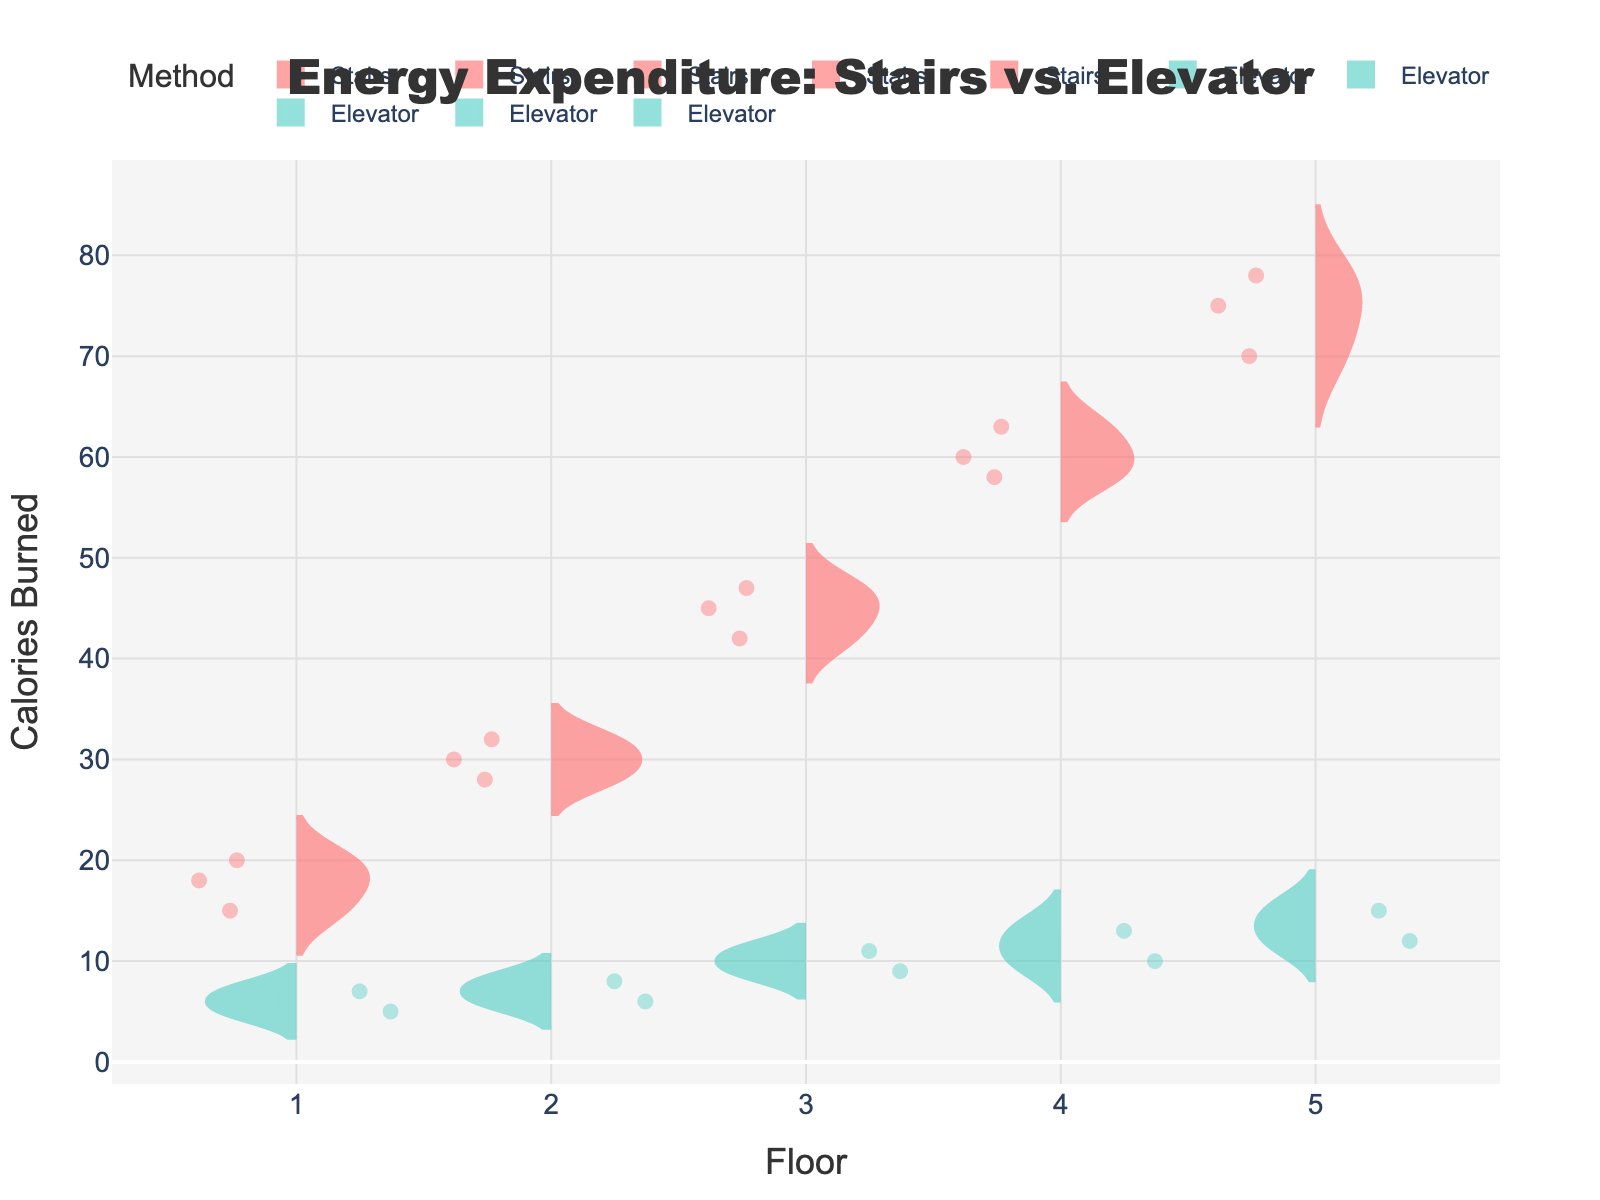How many colors are used in the violin plot? The figure uses two distinct colors to represent different methods (Stairs and Elevator). These colors help in distinguishing between the two methods visually.
Answer: Two What is the title of the figure? The title of the figure is displayed at the top center of the plot. It provides a summary of what the figure represents.
Answer: Energy Expenditure: Stairs vs. Elevator Which floor has the highest average calories burned for tenants using the stairs? When looking at the mean lines visible in the violin plots for each floor, the highest average calories burned for using the stairs is at floor 5.
Answer: Floor 5 What is the median calories burned for tenants using the elevator on the 3rd floor? By referring to the middle value indicated within the violin plot for the elevator method on the 3rd floor, we can find the median.
Answer: 10 calories How does the calorie expenditure compare between using the stairs and the elevator on the 2nd floor? Comparing the violin plots for stairs and elevator methods on the 2nd floor, we see that the calories burned are significantly higher for using the stairs than the elevator. The mean line for stairs is around 30 calories, while for the elevator, it is around 7 calories.
Answer: Stairs burn more calories What is the range of calories burned for tenants using the stairs on the 4th floor? The range can be determined by looking at the spread from the minimum to the maximum values within the violin plot for the stairs method on the 4th floor.
Answer: 58-63 calories Which method shows more variability in calories burned across all floors? Variability can be observed through the width and distribution of the violin plots. Comparing all floors, the stairs method shows more variability because the spread and the range of calories burned are wider than the elevator method.
Answer: Stairs Do any floors have overlapping calorie expenditures between the stairs and elevator methods? Examining each floor's violin plots, the 1st and 3rd floors show some overlap in the calorie expenditure ranges between the stairs and elevator methods.
Answer: 1st and 3rd floors How does the average calories burned for taking the stairs change as the floor number increases? Observing the mean lines for the stairs method across different floors, the average calories burned increases progressively from the 1st floor to the 5th floor.
Answer: Increases What can you infer about the overall physical activity level required for using stairs vs. the elevator? By comparing all the violin plots, it is clear that the stairs consistently require higher energy expenditure than the elevator. This suggests that using the stairs involves a greater level of physical activity compared to taking the elevator.
Answer: Stairs require higher physical activity 